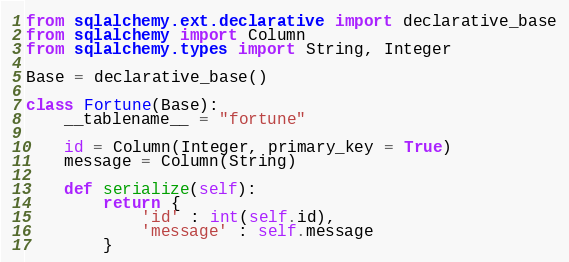Convert code to text. <code><loc_0><loc_0><loc_500><loc_500><_Python_>from sqlalchemy.ext.declarative import declarative_base
from sqlalchemy import Column
from sqlalchemy.types import String, Integer

Base = declarative_base()

class Fortune(Base):
    __tablename__ = "fortune"

    id = Column(Integer, primary_key = True)
    message = Column(String)

    def serialize(self):
        return {
            'id' : int(self.id),
            'message' : self.message
        }
</code> 